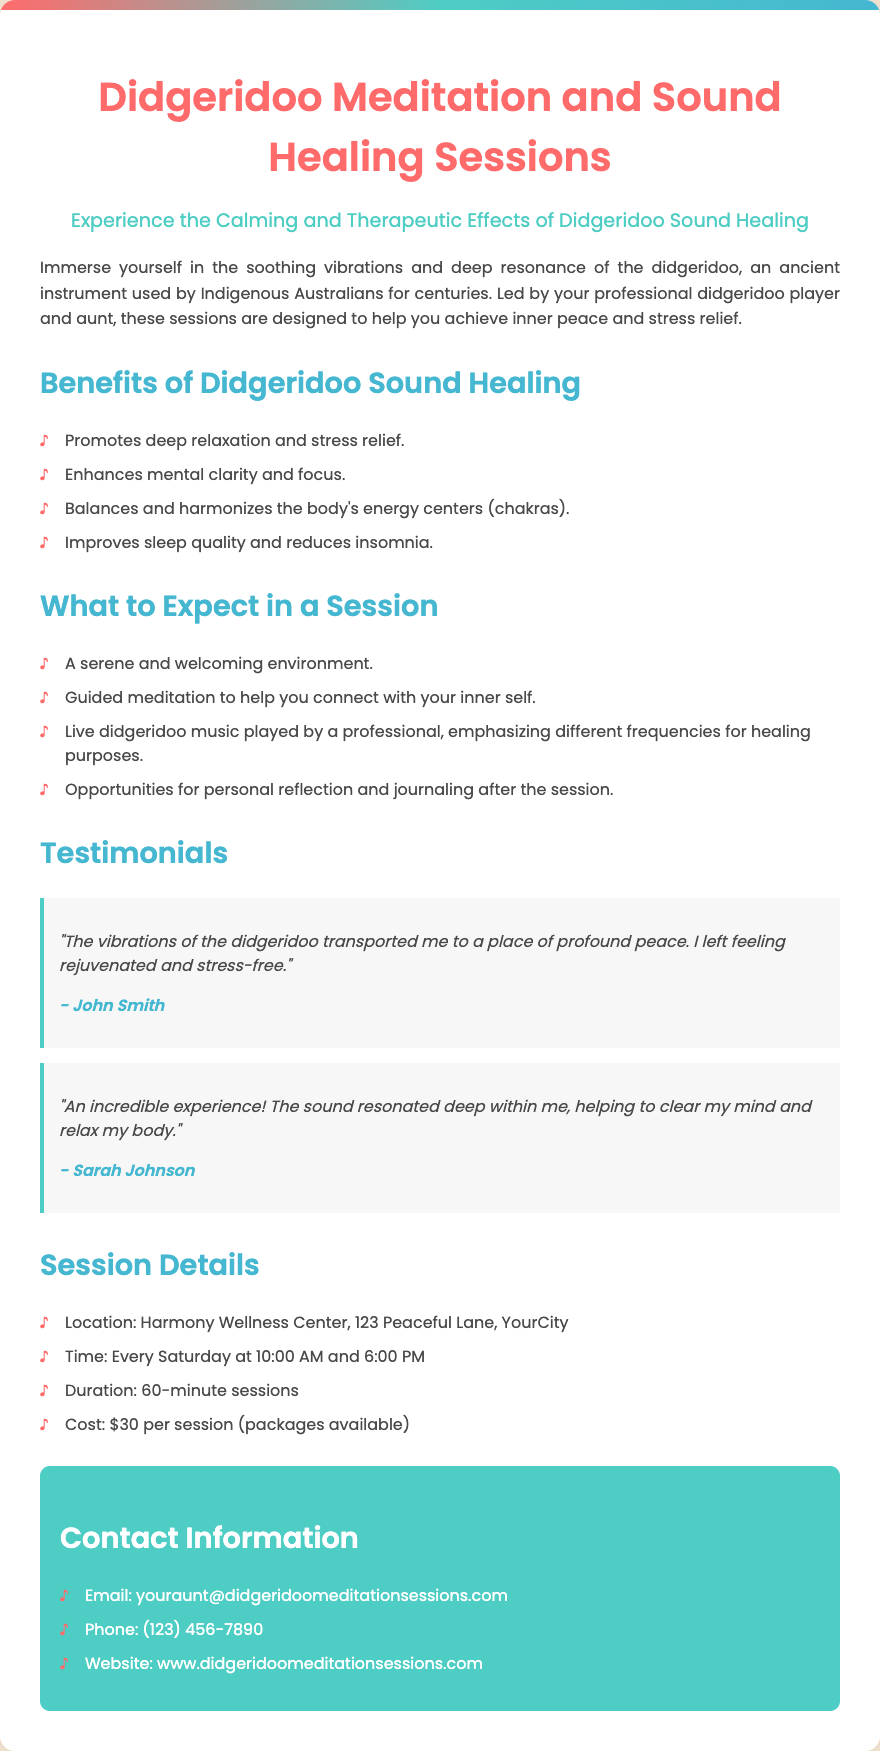What are the session times? The document states that the sessions are held every Saturday at 10:00 AM and 6:00 PM.
Answer: 10:00 AM and 6:00 PM Where is the location of the sessions? The document specifies the location as Harmony Wellness Center, 123 Peaceful Lane, YourCity.
Answer: Harmony Wellness Center, 123 Peaceful Lane, YourCity What is the cost per session? The document mentions that the cost for each session is $30, with packages available.
Answer: $30 What is one benefit of Didgeridoo Sound Healing? The document lists several benefits, one being that it promotes deep relaxation and stress relief.
Answer: Promotes deep relaxation and stress relief What is included in a session? The document outlines that a session includes guided meditation to connect with your inner self.
Answer: Guided meditation to help you connect with your inner self How long is each session? The document indicates that each session lasts for 60 minutes.
Answer: 60 minutes Who is leading the sessions? The document states that the sessions are led by a professional didgeridoo player who is also your aunt.
Answer: A professional didgeridoo player (your aunt) What type of music is played during the session? The document describes that live didgeridoo music is played, emphasizing different frequencies for healing purposes.
Answer: Live didgeridoo music What is a testimonial about the experience? The testimonials provided in the document convey that participants felt rejuvenated and stress-free.
Answer: "The vibrations of the didgeridoo transported me to a place of profound peace." 